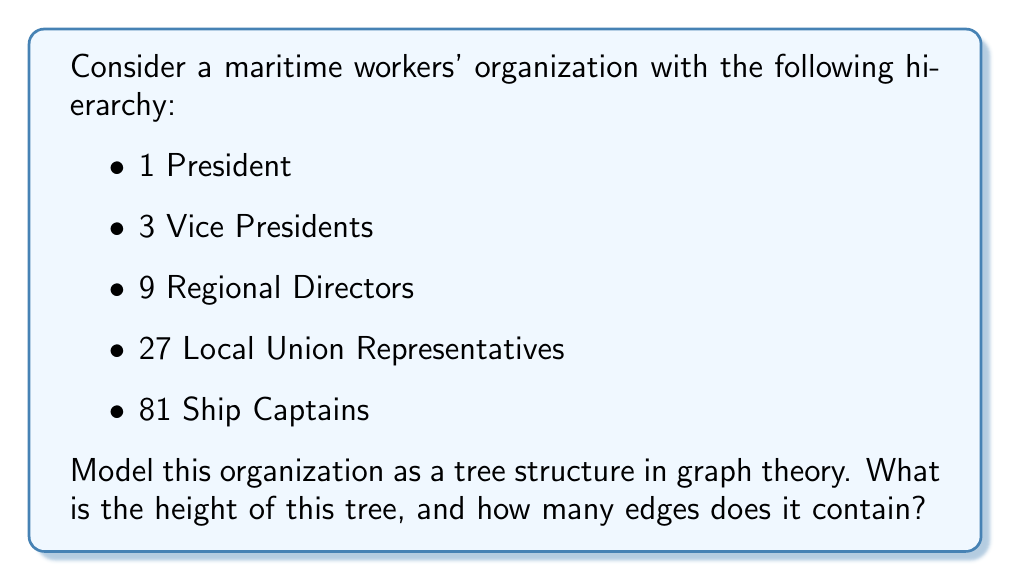Help me with this question. Let's approach this step-by-step:

1) First, we need to understand the structure of the tree:
   - The President is at the top (root)
   - Each Vice President reports to the President
   - Each Regional Director reports to a Vice President
   - Each Local Union Representative reports to a Regional Director
   - Each Ship Captain reports to a Local Union Representative

2) To find the height of the tree:
   - The height is the number of edges in the longest path from the root to a leaf
   - In this case, it's the path from President to Ship Captain
   - Count the levels: President -> Vice President -> Regional Director -> Local Union Representative -> Ship Captain
   - This gives us 4 edges in the longest path

3) To find the total number of edges:
   - In a tree, the number of edges is always one less than the number of nodes
   - Let's count the total number of nodes:
     1 (President) + 3 (VPs) + 9 (Regional Directors) + 27 (Local Reps) + 81 (Captains) = 121
   - Therefore, the number of edges is 121 - 1 = 120

We can verify this by counting edges level by level:
   - President to VPs: 3 edges
   - VPs to Regional Directors: 3 * 3 = 9 edges
   - Regional Directors to Local Reps: 9 * 3 = 27 edges
   - Local Reps to Captains: 27 * 3 = 81 edges
   Total: 3 + 9 + 27 + 81 = 120 edges

The tree can be represented mathematically as a 4-ary tree (each non-leaf node has 3 children) with 5 levels.
Answer: The height of the tree is 4, and it contains 120 edges. 